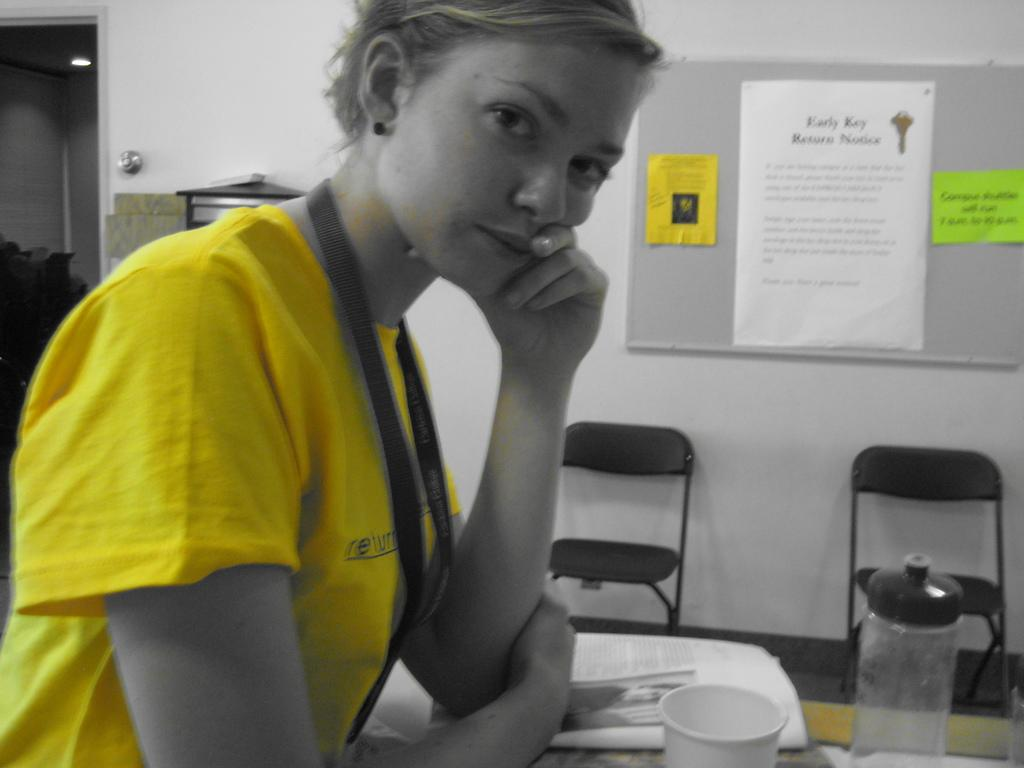<image>
Summarize the visual content of the image. A woman wearing a yellow shirt standing in front of a bulletin board listing the early key return notice. 